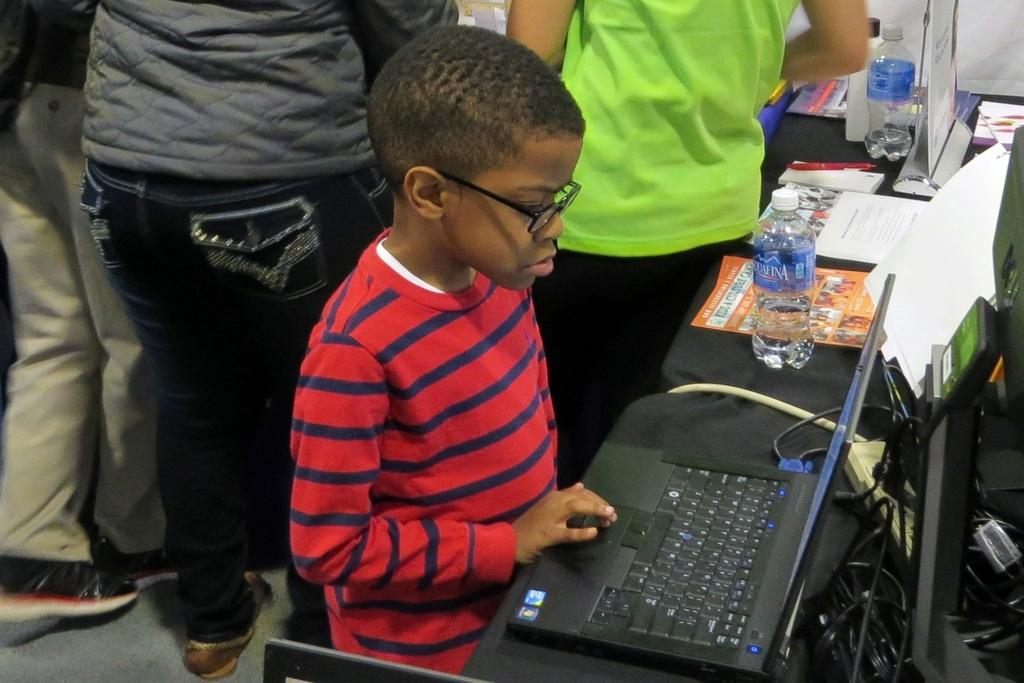Who is the main subject in the image? There is a boy in the image. What is the boy doing in the image? The boy is using a laptop. What can be seen on the right side of the image? There are water bottles on the right side of the image. What is visible in the background of the image? There are people in the background of the image. What type of wrench is the boy using on the laptop in the image? There is no wrench present in the image; the boy is using a laptop, not a wrench. What team is the boy a part of in the image? There is no indication of a team in the image; it simply shows a boy using a laptop. 